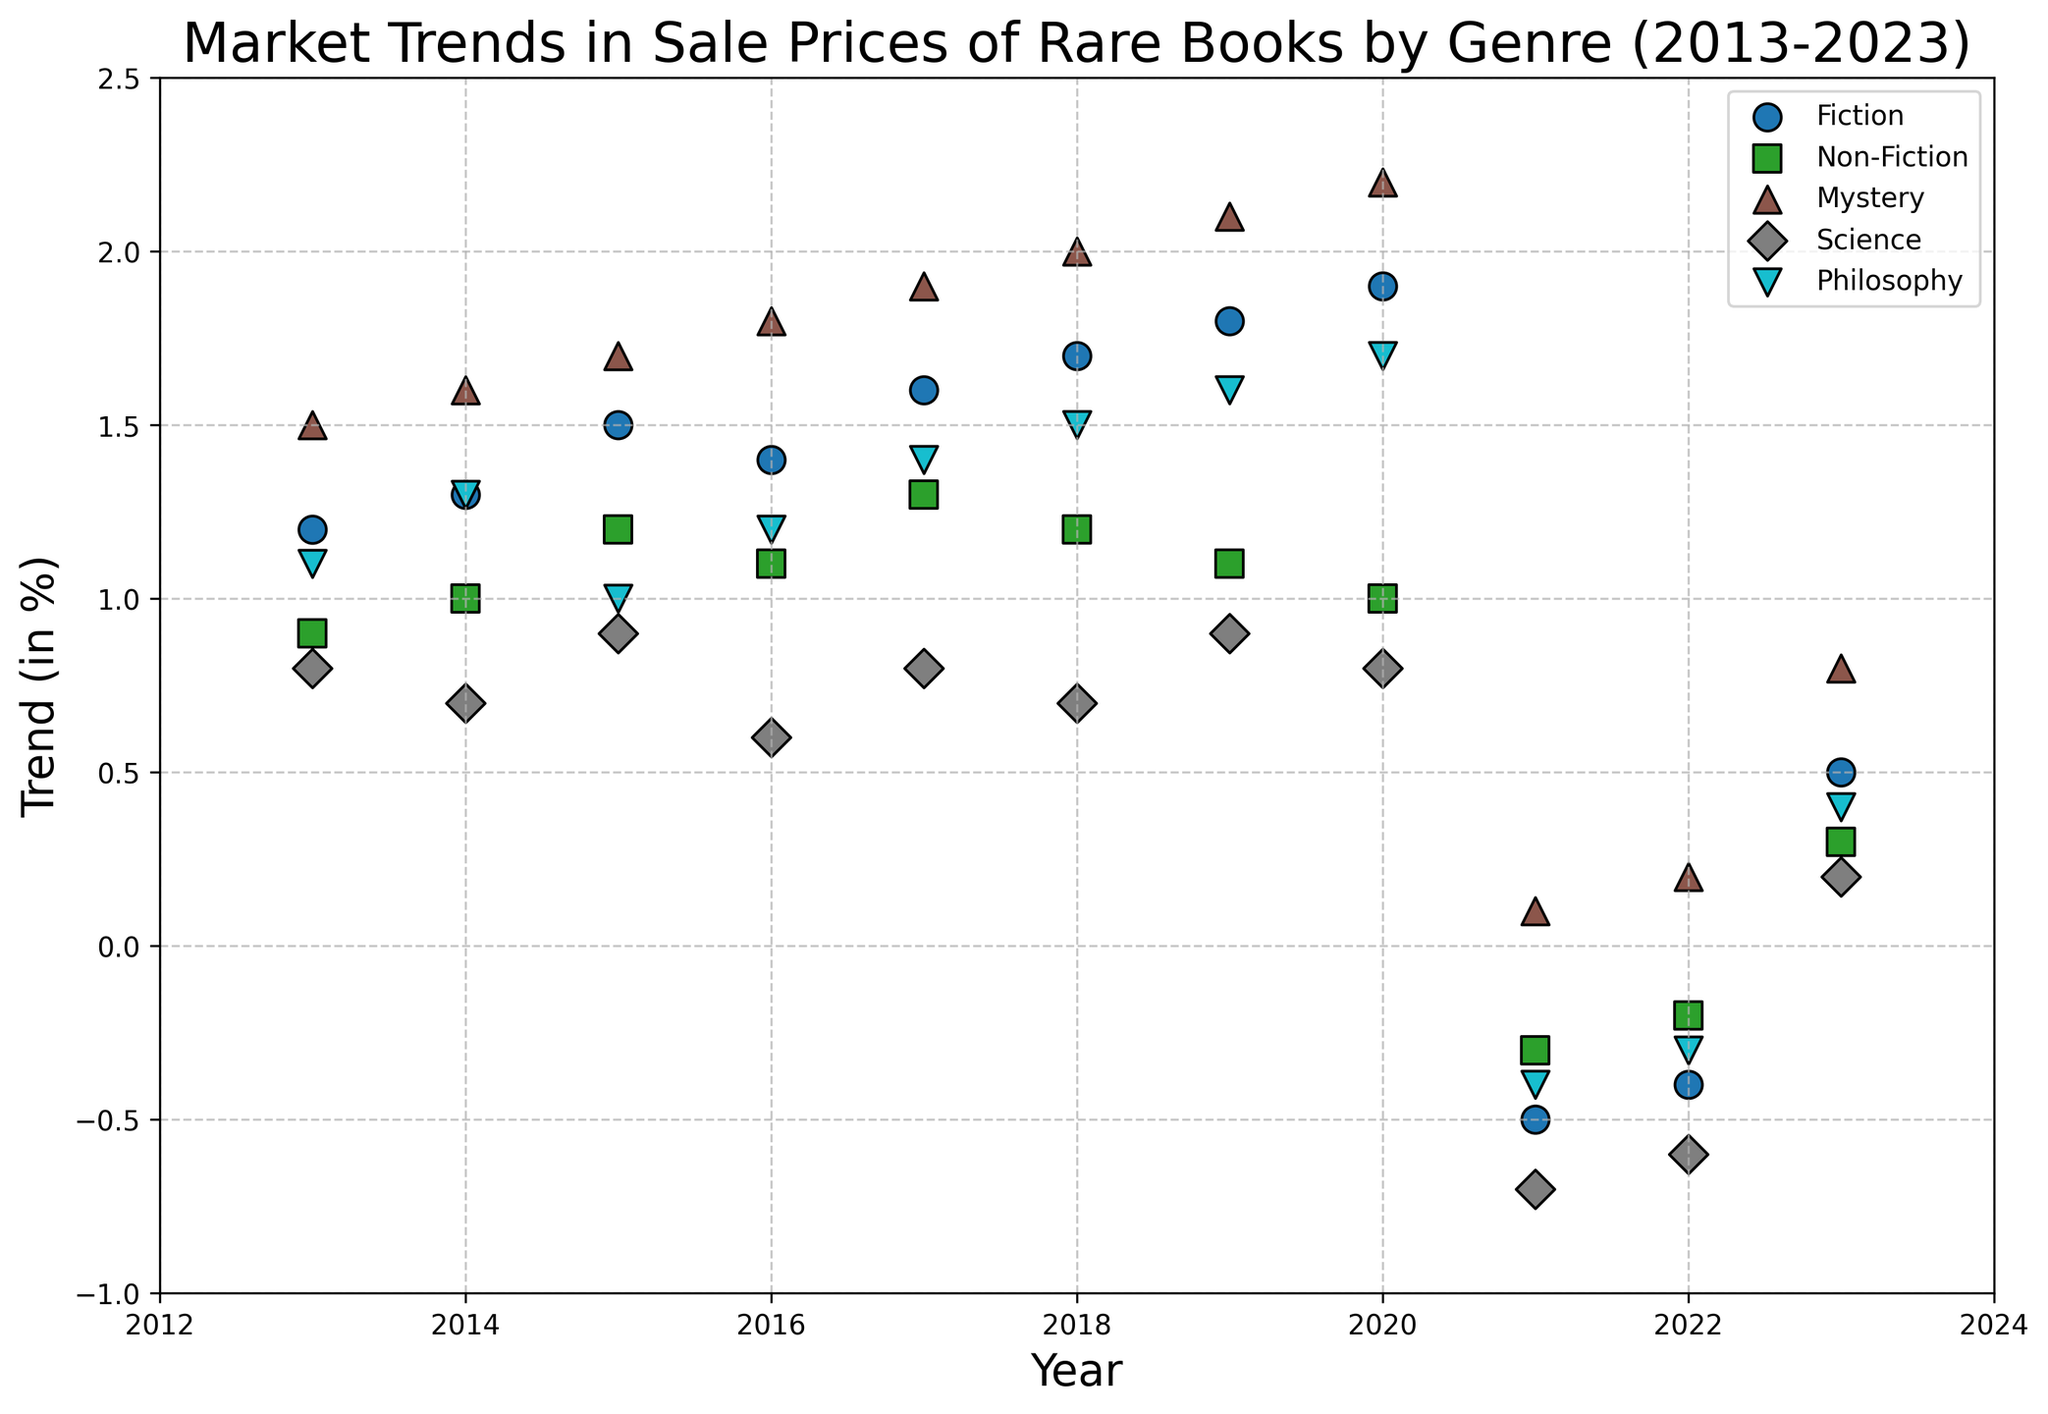How did the trend in sales prices for Fiction books change between 2021 and 2023? To answer this, observe the points corresponding to Fiction in the years 2021 and 2023. In 2021, the trend is -0.5, and in 2023, it is 0.5. The change is calculated by subtracting the 2021 value from the 2023 value: 0.5 - (-0.5) = 1.0.
Answer: 1.0 Which genre had the highest trend increase from 2020 to 2023? Look at the trends in 2020 and 2023 for all genres. Calculate the difference for each genre: Fiction (0.5 - 1.9 = -1.4), Non-Fiction (0.3 - 1.0 = -0.7), Mystery (0.8 - 2.2 = -1.4), Science (0.2 - 0.8 = -0.6), Philosophy (0.4 - 1.7 = -1.3). The genre with the highest increase would have the least negative difference, which is Science with -0.6.
Answer: Science What was the trend for the Mystery genre in 2018? Locate the point corresponding to the Mystery genre in 2018. The trend is represented by the y-axis value. From the plot, the Mystery genre has a trend of 2.0 in 2018.
Answer: 2.0 By how much did the trend for Non-Fiction books decline from 2020 to 2021? Identify the Non-Fiction trend values for 2020 and 2021: 1.0 and -0.3 respectively. Calculate the decline: 1.0 - (-0.3) = 1.3.
Answer: 1.3 Which year recorded the lowest trend for Science books? Observe the points for the Science genre between 2013 and 2023, and identify the year with the lowest value on the y-axis, which is 2021 with -0.7.
Answer: 2021 Between Fiction and Philosophy books, which had a higher trend in the year 2017? Compare the trends for Fiction and Philosophy for the year 2017. Fiction has a trend of 1.6, and Philosophy has a trend of 1.4. Fiction's trend is higher.
Answer: Fiction In which year did the Philosophy genre have a negative trend? Look for points under the Philosophy genre below the x-axis (negative values). The negative trend is observed in 2021 and 2022. The years are 2021 and 2022.
Answer: 2021 and 2022 What is the average trend for Mystery books over the entire period? Sum the trend values for Mystery over the years and divide by the number of years: (1.5 + 1.6 + 1.7 + 1.8 + 1.9 + 2.0 + 2.1 + 2.2 + 0.1 + 0.2 + 0.8) / 11 = 1.436.
Answer: 1.436 How did the trend for Philosophy books change from 2018 to 2019? Check the trend values for Philosophy in 2018 and 2019, which are 1.5 and 1.6. The difference is 1.6 - 1.5 = 0.1.
Answer: 0.1 